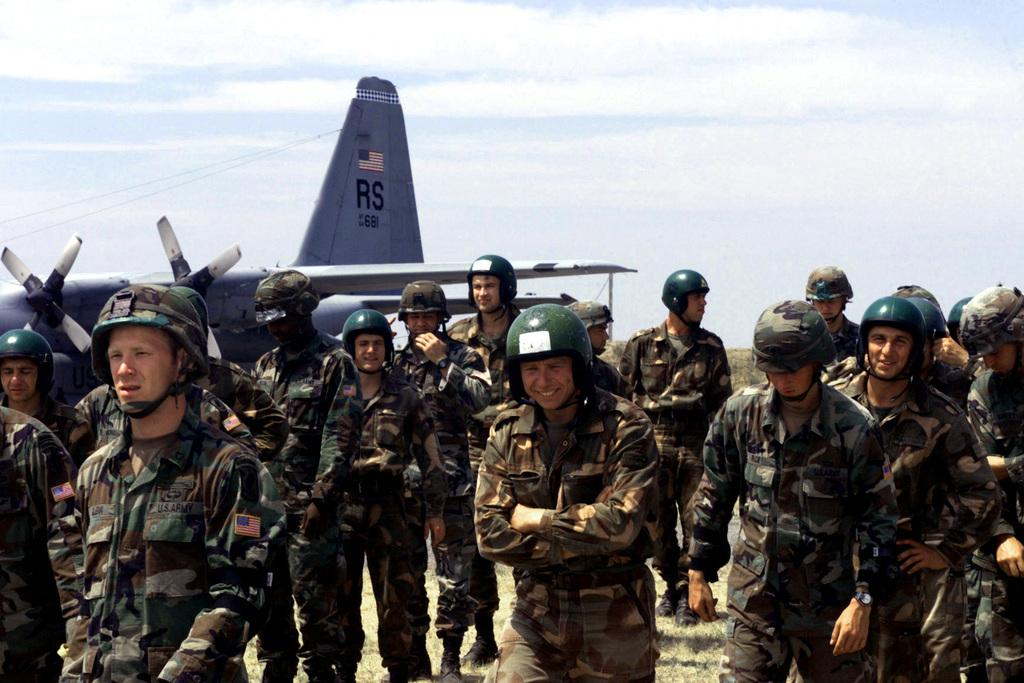Who or what can be seen in the image? There are people in the image. What are the people wearing on their heads? The people are wearing helmets. What type of vehicle is present in the image? There is a jet plane in the image. How would you describe the sky in the image? The sky is blue and cloudy. What type of powder is being used by the expert in the image? There is no expert or powder present in the image. Can you tell me how many flights are taking off in the image? There is only one jet plane visible in the image, and it is not taking off. 